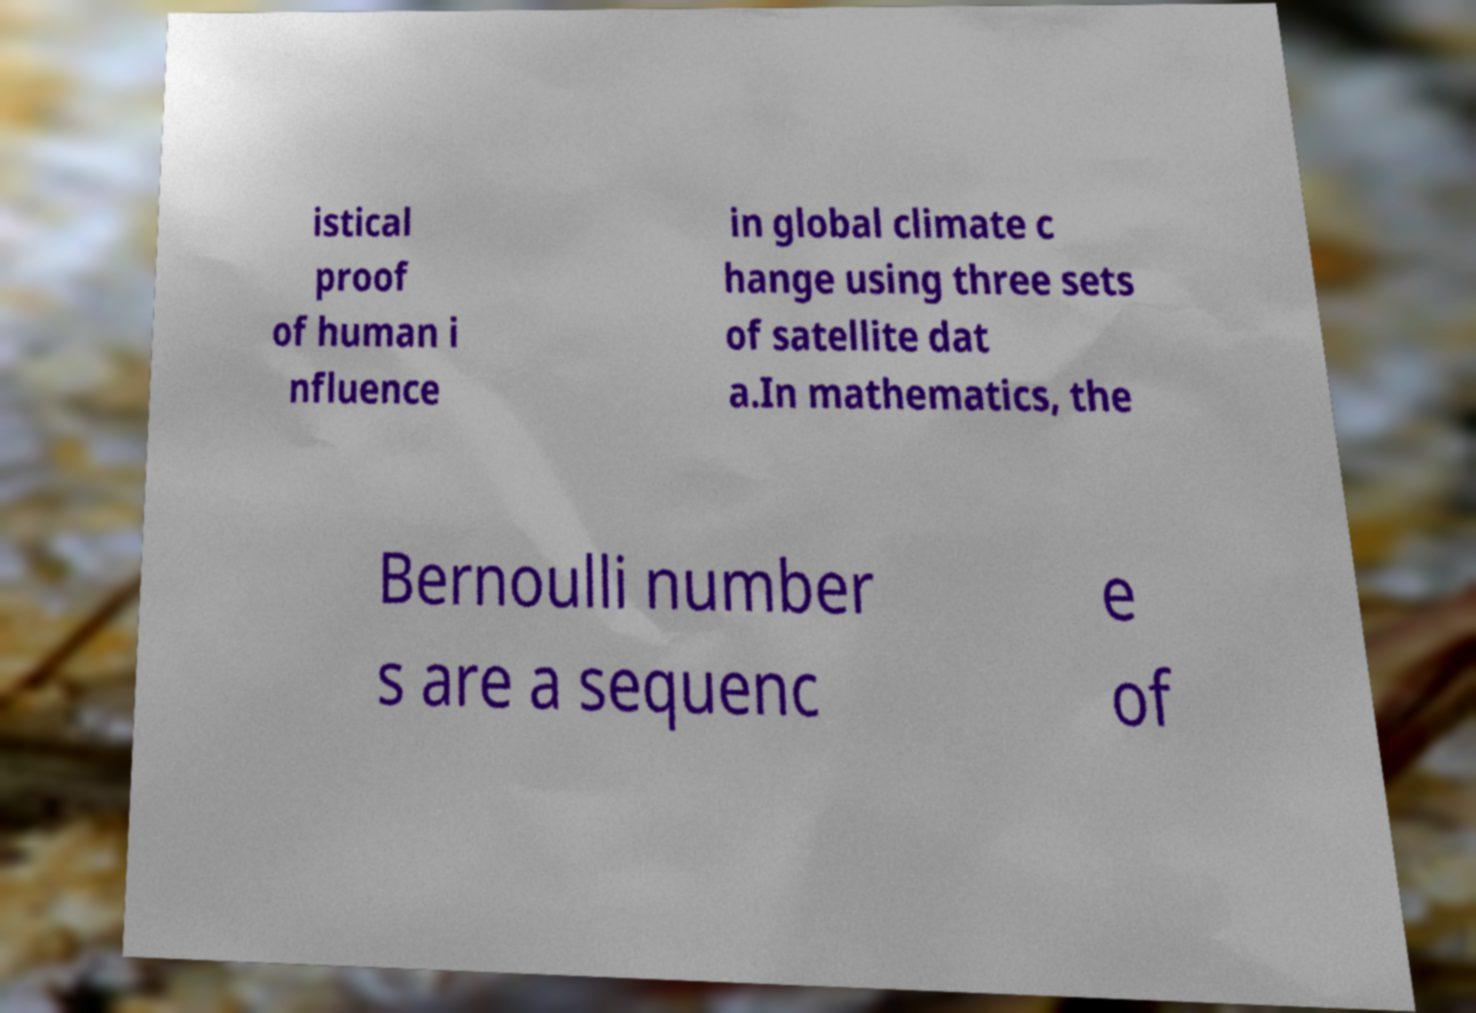For documentation purposes, I need the text within this image transcribed. Could you provide that? istical proof of human i nfluence in global climate c hange using three sets of satellite dat a.In mathematics, the Bernoulli number s are a sequenc e of 